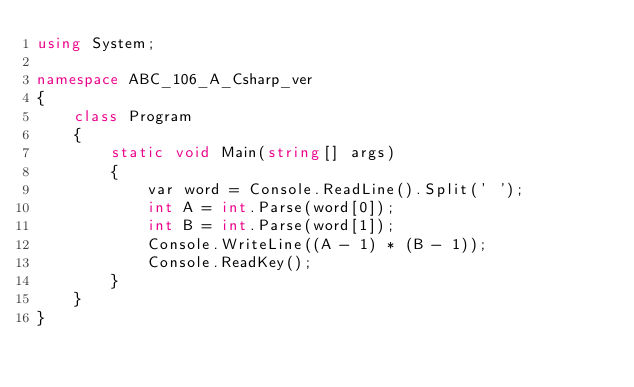Convert code to text. <code><loc_0><loc_0><loc_500><loc_500><_C#_>using System;

namespace ABC_106_A_Csharp_ver
{
    class Program
    {
        static void Main(string[] args)
        {
            var word = Console.ReadLine().Split(' ');
            int A = int.Parse(word[0]);
            int B = int.Parse(word[1]);
            Console.WriteLine((A - 1) * (B - 1));
            Console.ReadKey();
        }
    }
}
</code> 